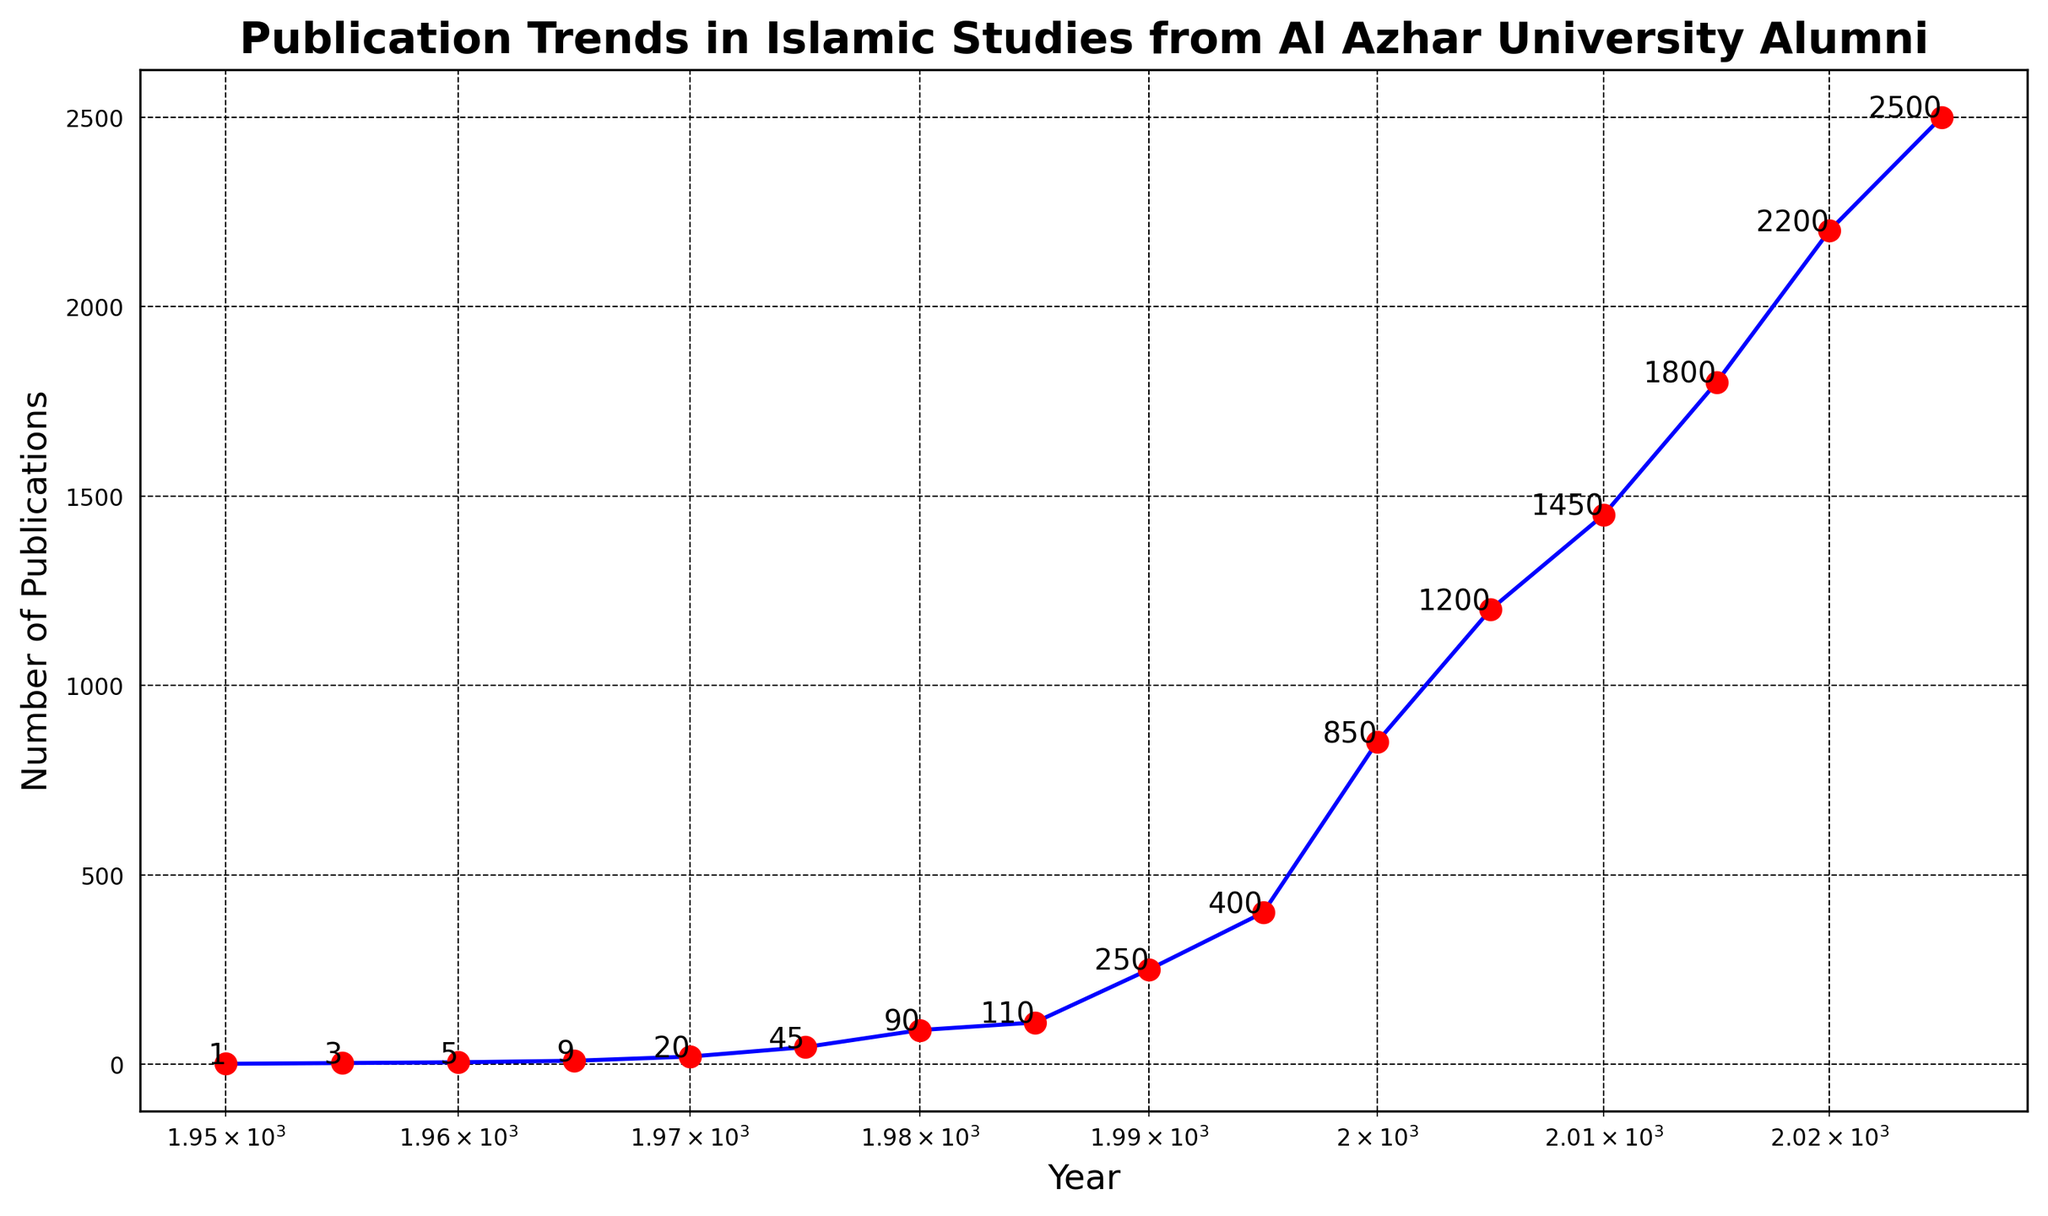What trend can you observe in the number of publications from 1950 to 2025? The number of publications shows a significant increase over time, starting from 1 publication in 1950 and rising to 2500 publications in 2025. The trend is upward and exponential.
Answer: Exponential increase What was the number of publications in the year 2000? Referring to the figure, the number of publications in the year 2000 is marked close to 850.
Answer: 850 Between which two consecutive years did the number of publications increase the most? To find the year with the maximum increase, subtract the number of publications of consecutive years and find the highest value. The increase from 1995 (400) to 2000 (850) is 450, which is the highest.
Answer: 1995 to 2000 When did the publications first surpass 1000? By examining the plot, the first point where the number of publications is more than 1000 is in the year 2005.
Answer: 2005 How does the number of publications in 1980 compare to 1990? In 1980, there were 90 publications and in 1990, there were 250 publications. 250 is significantly greater than 90.
Answer: 1990 has more publications Estimate the average growth in the number of publications per 5-year period between 1950 and 1975. Sum up the number of publications from 1950 to 1975 then divide by the number of periods (5). (1 + 3 + 5 + 9 + 20 + 45) / 5 = 83 / 5 = 16.6
Answer: ~16.6 per period What visual element highlights the significant increase in publications after 1970? The use of a log scale on the x-axis and the marked increase in the gradient of the plot line after 1970 visually highlights this increase.
Answer: Log scale and steep gradient What is the publication count difference between the years 2015 and 2020? Subtract the number of publications in 2015 from those in 2020: 2200 - 1800 = 400.
Answer: 400 When examining the figure, which color marks the data points, and what color is used for the line plot? The data points are marked in red and the line plot is in blue.
Answer: Red points, blue line What is the main trend observed over the entire period, and what might this suggest? The main trend is a continuous and exponential increase in the number of publications. This suggests growing interest and active research contributions in Islamic Studies by Al Azhar University Alumni over the years.
Answer: Continuous exponential growth 